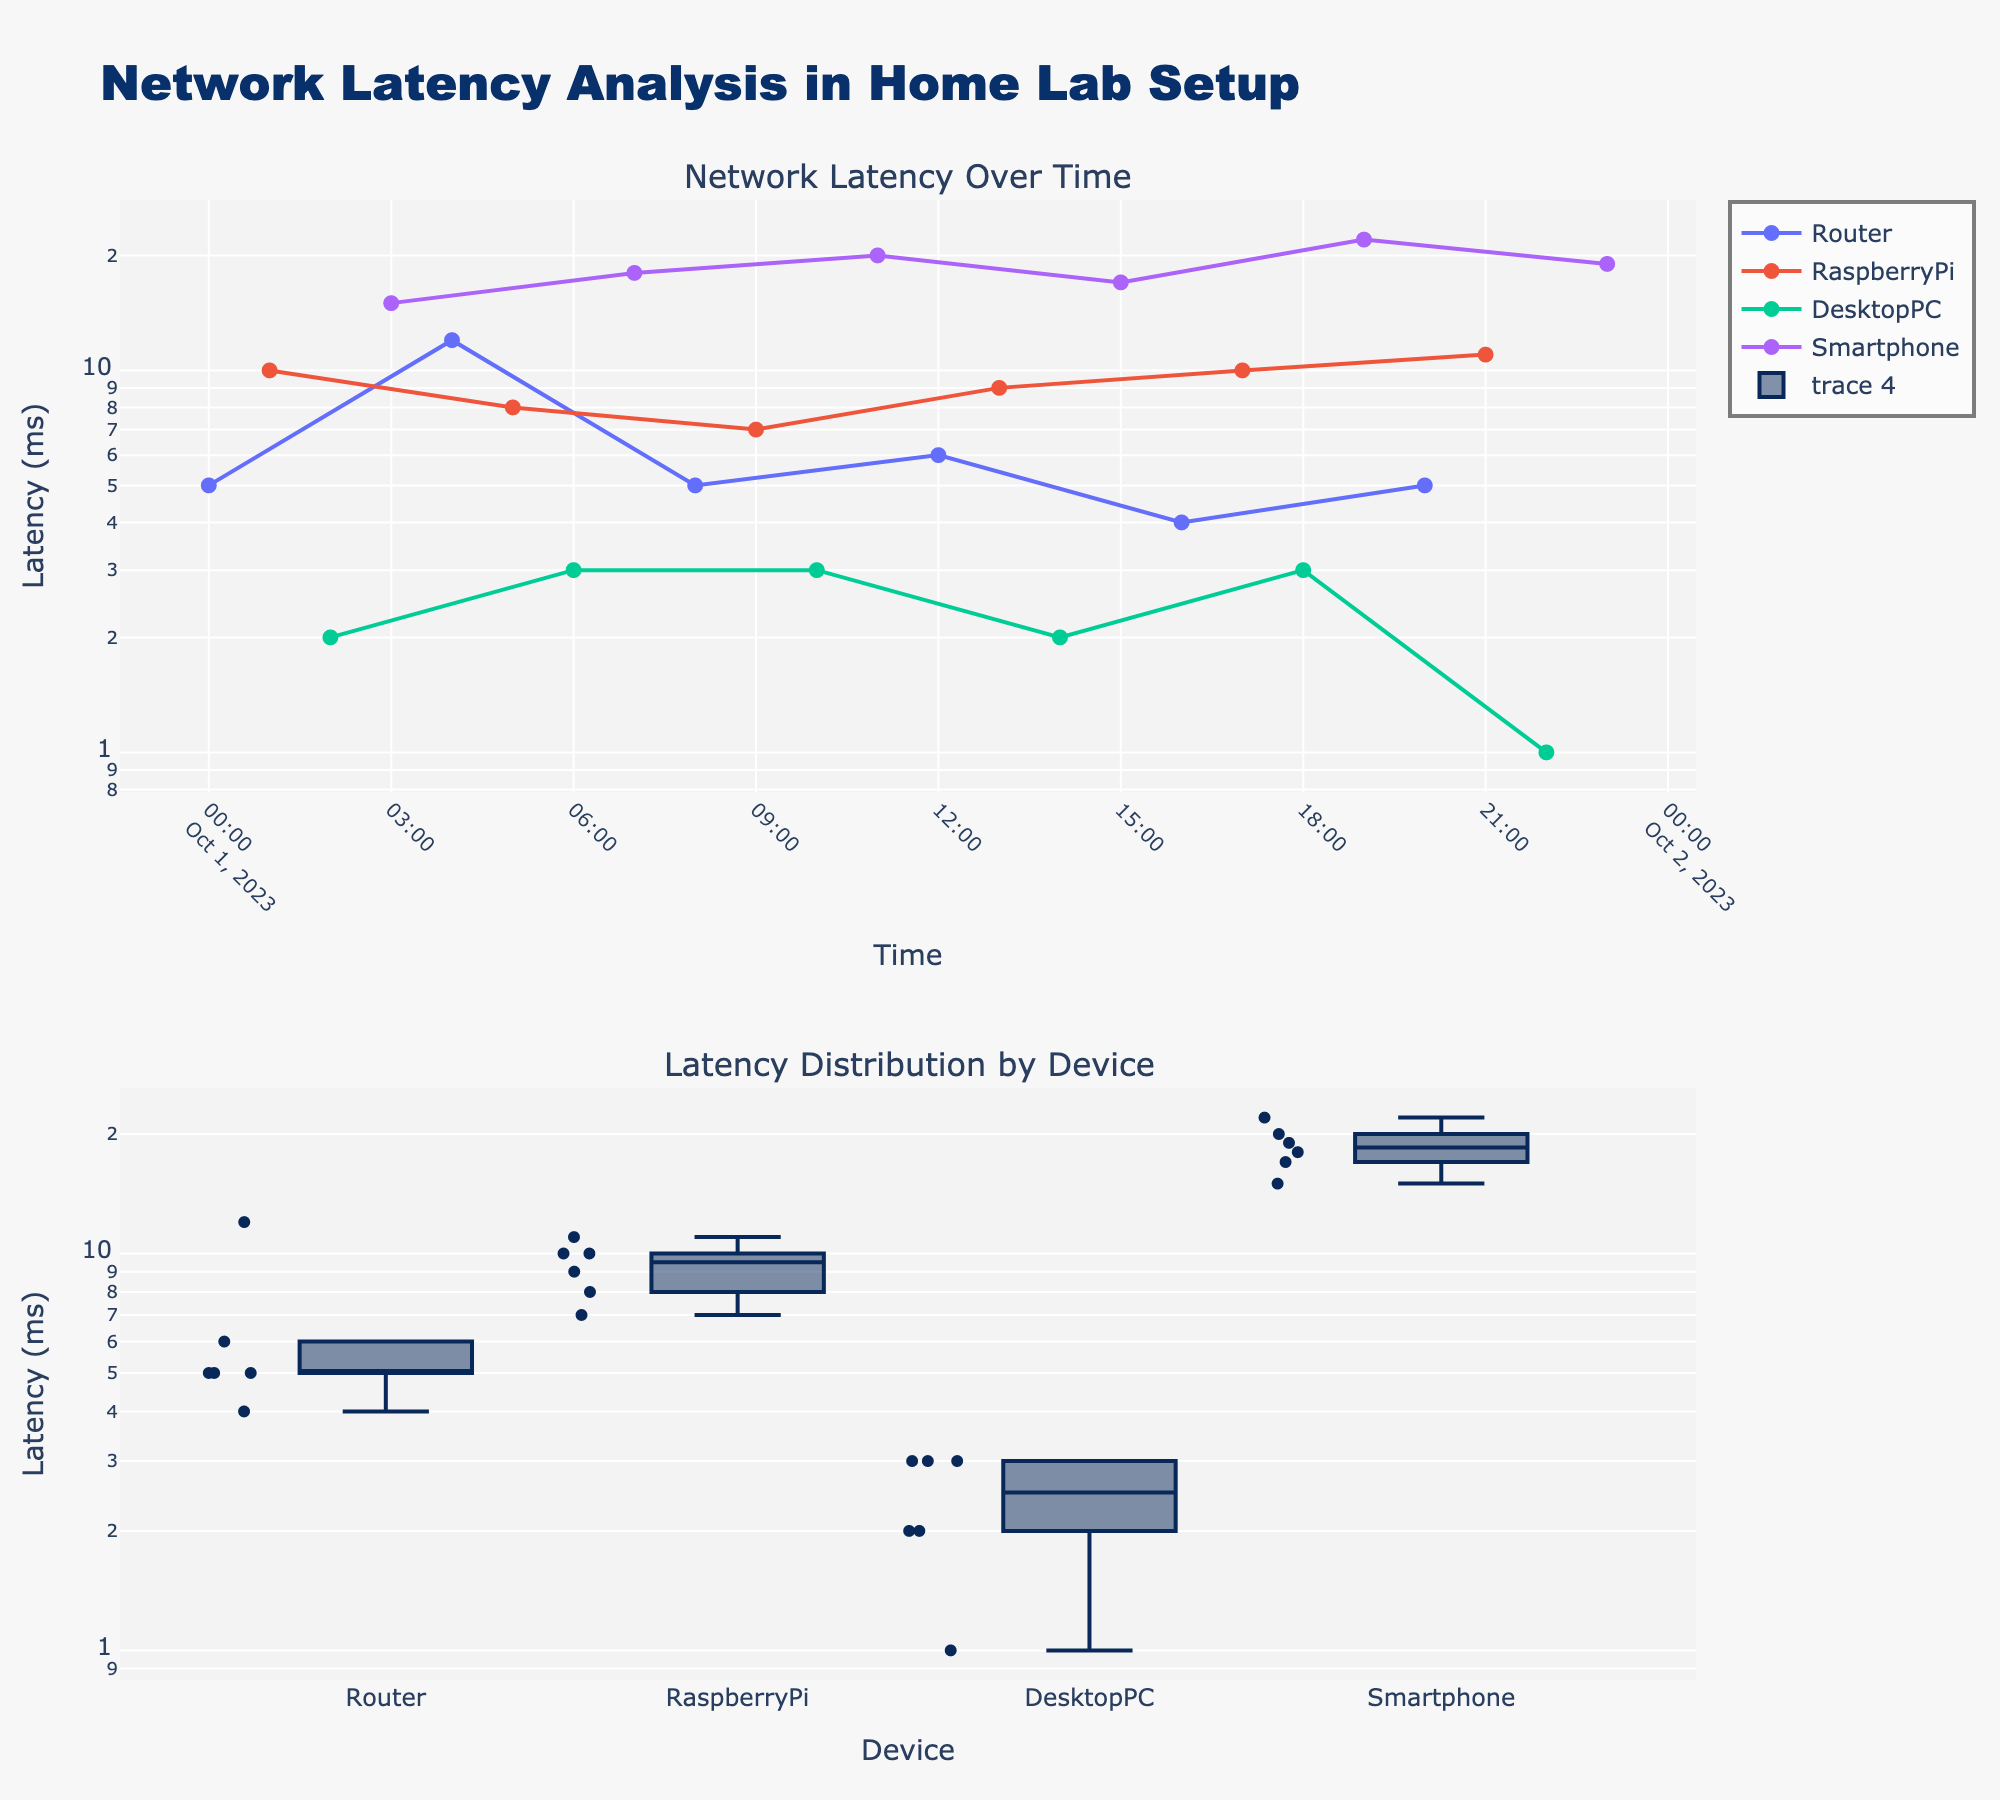What is the title of the figure? The title is located at the top center of the figure and it clearly states the main focus of the plot. "Network Latency Analysis in Home Lab Setup" is the text presented in a noticeable font size.
Answer: Network Latency Analysis in Home Lab Setup How are the y-axes scaled in the two subplots? Both y-axes are labeled as "Latency (ms)" with the added descriptor of "type='log'", indicating that the scales are logarithmic rather than linear.
Answer: Logarithmic Which device has the lowest latency, and what was the value? By looking at the lower plot and scanning the box plot or the individual data points near the base of the axis, DesktopPC has the lowest latency with a minimum value around 1 ms.
Answer: DesktopPC, 1 ms What is the general trend in latency measurements for the "Smartphone" device over time? In the upper plot, tracing the line for "Smartphone" from left to right, the latencies appear to increase over time, with values starting low and peaking at higher levels later.
Answer: Increasing trend How many latency measurements were taken between 00:00 and 12:00? Refer to the upper subplot, count the frequency of data points for all devices within the given time range. The total counts for each device are Router (3), RaspberryPi (3), DesktopPC (3), Smartphone (3). Summing these gives us 12 measurements.
Answer: 12 Which device shows the highest variability in latency, and how can you tell? The lower subplot showing box plots highlights that the "Smartphone" has a taller box and wider range, suggesting the greatest variability in latency measurements.
Answer: Smartphone What is the median latency for the "RaspberryPi" device? In the lower subplot, identifying the center line within the box plot for "RaspberryPi" provides the median. The median value looks to be approximately 9 ms.
Answer: 9 ms Which device consistently shows the lowest latency across the network? Both plots can be checked, but primarily focus on the lower subplot. "DesktopPC" consistently shows the smallest latency values compared to the other devices.
Answer: DesktopPC 